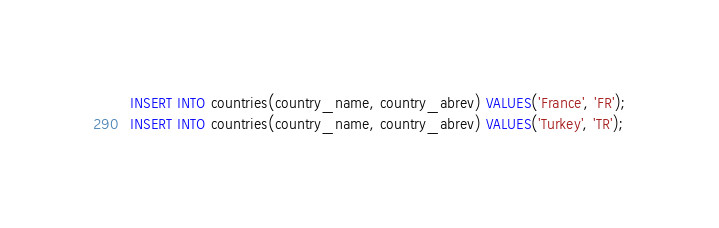<code> <loc_0><loc_0><loc_500><loc_500><_SQL_>INSERT INTO countries(country_name, country_abrev) VALUES('France', 'FR');
INSERT INTO countries(country_name, country_abrev) VALUES('Turkey', 'TR');

</code> 